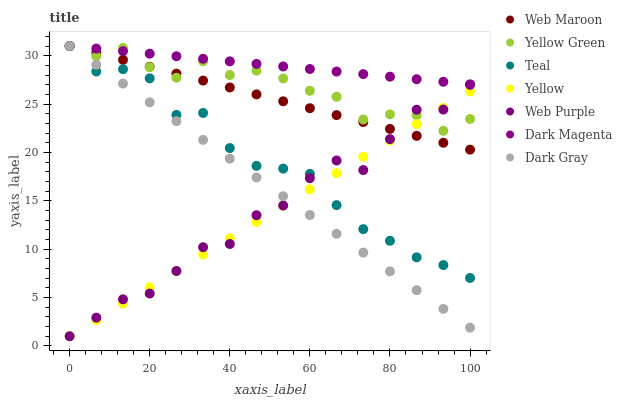Does Yellow have the minimum area under the curve?
Answer yes or no. Yes. Does Dark Magenta have the maximum area under the curve?
Answer yes or no. Yes. Does Web Maroon have the minimum area under the curve?
Answer yes or no. No. Does Web Maroon have the maximum area under the curve?
Answer yes or no. No. Is Yellow the smoothest?
Answer yes or no. Yes. Is Web Purple the roughest?
Answer yes or no. Yes. Is Web Maroon the smoothest?
Answer yes or no. No. Is Web Maroon the roughest?
Answer yes or no. No. Does Yellow have the lowest value?
Answer yes or no. Yes. Does Web Maroon have the lowest value?
Answer yes or no. No. Does Dark Magenta have the highest value?
Answer yes or no. Yes. Does Yellow have the highest value?
Answer yes or no. No. Is Web Purple less than Dark Magenta?
Answer yes or no. Yes. Is Dark Magenta greater than Yellow?
Answer yes or no. Yes. Does Yellow Green intersect Teal?
Answer yes or no. Yes. Is Yellow Green less than Teal?
Answer yes or no. No. Is Yellow Green greater than Teal?
Answer yes or no. No. Does Web Purple intersect Dark Magenta?
Answer yes or no. No. 